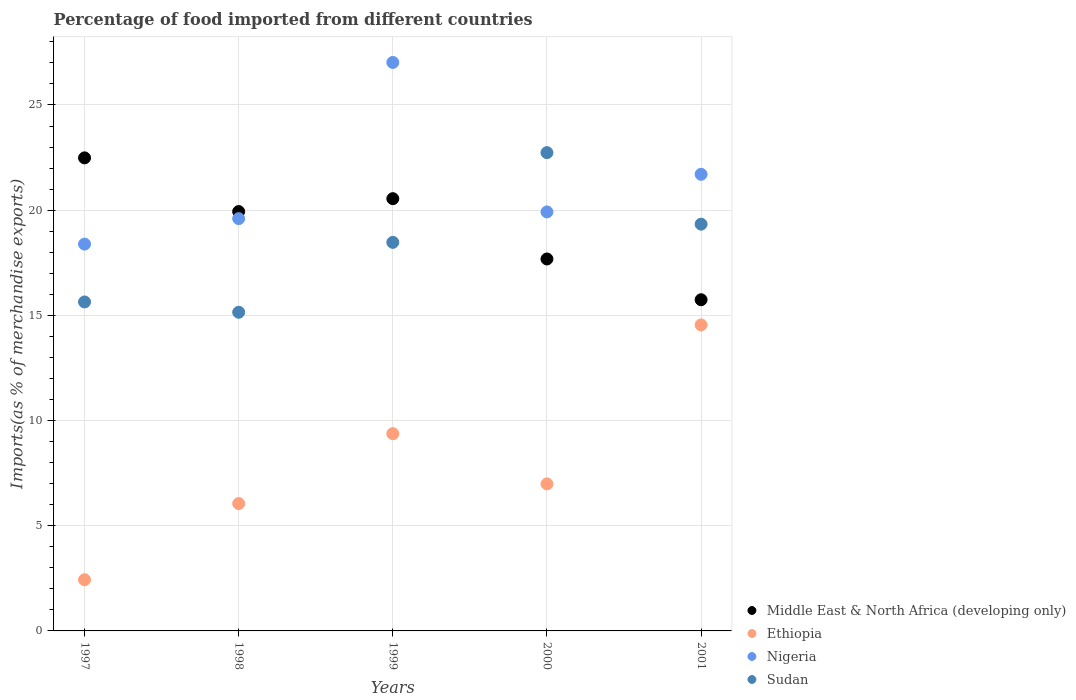How many different coloured dotlines are there?
Keep it short and to the point. 4. Is the number of dotlines equal to the number of legend labels?
Your response must be concise. Yes. What is the percentage of imports to different countries in Sudan in 1999?
Provide a succinct answer. 18.47. Across all years, what is the maximum percentage of imports to different countries in Middle East & North Africa (developing only)?
Provide a short and direct response. 22.49. Across all years, what is the minimum percentage of imports to different countries in Ethiopia?
Your response must be concise. 2.43. What is the total percentage of imports to different countries in Middle East & North Africa (developing only) in the graph?
Give a very brief answer. 96.39. What is the difference between the percentage of imports to different countries in Sudan in 1997 and that in 1999?
Ensure brevity in your answer.  -2.83. What is the difference between the percentage of imports to different countries in Middle East & North Africa (developing only) in 1997 and the percentage of imports to different countries in Sudan in 2001?
Give a very brief answer. 3.15. What is the average percentage of imports to different countries in Nigeria per year?
Make the answer very short. 21.33. In the year 1997, what is the difference between the percentage of imports to different countries in Nigeria and percentage of imports to different countries in Ethiopia?
Keep it short and to the point. 15.95. In how many years, is the percentage of imports to different countries in Nigeria greater than 6 %?
Offer a terse response. 5. What is the ratio of the percentage of imports to different countries in Nigeria in 1999 to that in 2000?
Your answer should be very brief. 1.36. Is the percentage of imports to different countries in Middle East & North Africa (developing only) in 1997 less than that in 1998?
Ensure brevity in your answer.  No. What is the difference between the highest and the second highest percentage of imports to different countries in Ethiopia?
Make the answer very short. 5.17. What is the difference between the highest and the lowest percentage of imports to different countries in Ethiopia?
Provide a succinct answer. 12.11. Does the percentage of imports to different countries in Nigeria monotonically increase over the years?
Offer a terse response. No. How many years are there in the graph?
Keep it short and to the point. 5. What is the difference between two consecutive major ticks on the Y-axis?
Your answer should be very brief. 5. Does the graph contain any zero values?
Provide a short and direct response. No. How are the legend labels stacked?
Ensure brevity in your answer.  Vertical. What is the title of the graph?
Your answer should be compact. Percentage of food imported from different countries. Does "Indonesia" appear as one of the legend labels in the graph?
Offer a very short reply. No. What is the label or title of the X-axis?
Give a very brief answer. Years. What is the label or title of the Y-axis?
Provide a short and direct response. Imports(as % of merchandise exports). What is the Imports(as % of merchandise exports) of Middle East & North Africa (developing only) in 1997?
Your answer should be very brief. 22.49. What is the Imports(as % of merchandise exports) of Ethiopia in 1997?
Your answer should be compact. 2.43. What is the Imports(as % of merchandise exports) of Nigeria in 1997?
Make the answer very short. 18.39. What is the Imports(as % of merchandise exports) in Sudan in 1997?
Your answer should be very brief. 15.64. What is the Imports(as % of merchandise exports) in Middle East & North Africa (developing only) in 1998?
Provide a succinct answer. 19.93. What is the Imports(as % of merchandise exports) in Ethiopia in 1998?
Keep it short and to the point. 6.05. What is the Imports(as % of merchandise exports) in Nigeria in 1998?
Offer a very short reply. 19.6. What is the Imports(as % of merchandise exports) of Sudan in 1998?
Ensure brevity in your answer.  15.15. What is the Imports(as % of merchandise exports) of Middle East & North Africa (developing only) in 1999?
Your answer should be compact. 20.55. What is the Imports(as % of merchandise exports) in Ethiopia in 1999?
Your answer should be compact. 9.38. What is the Imports(as % of merchandise exports) of Nigeria in 1999?
Your response must be concise. 27.02. What is the Imports(as % of merchandise exports) in Sudan in 1999?
Your response must be concise. 18.47. What is the Imports(as % of merchandise exports) in Middle East & North Africa (developing only) in 2000?
Keep it short and to the point. 17.68. What is the Imports(as % of merchandise exports) of Ethiopia in 2000?
Offer a very short reply. 6.99. What is the Imports(as % of merchandise exports) in Nigeria in 2000?
Ensure brevity in your answer.  19.92. What is the Imports(as % of merchandise exports) of Sudan in 2000?
Your answer should be very brief. 22.73. What is the Imports(as % of merchandise exports) of Middle East & North Africa (developing only) in 2001?
Provide a succinct answer. 15.74. What is the Imports(as % of merchandise exports) of Ethiopia in 2001?
Your response must be concise. 14.55. What is the Imports(as % of merchandise exports) in Nigeria in 2001?
Ensure brevity in your answer.  21.7. What is the Imports(as % of merchandise exports) of Sudan in 2001?
Keep it short and to the point. 19.33. Across all years, what is the maximum Imports(as % of merchandise exports) of Middle East & North Africa (developing only)?
Provide a succinct answer. 22.49. Across all years, what is the maximum Imports(as % of merchandise exports) in Ethiopia?
Your answer should be very brief. 14.55. Across all years, what is the maximum Imports(as % of merchandise exports) in Nigeria?
Keep it short and to the point. 27.02. Across all years, what is the maximum Imports(as % of merchandise exports) of Sudan?
Provide a succinct answer. 22.73. Across all years, what is the minimum Imports(as % of merchandise exports) in Middle East & North Africa (developing only)?
Make the answer very short. 15.74. Across all years, what is the minimum Imports(as % of merchandise exports) in Ethiopia?
Your answer should be compact. 2.43. Across all years, what is the minimum Imports(as % of merchandise exports) of Nigeria?
Ensure brevity in your answer.  18.39. Across all years, what is the minimum Imports(as % of merchandise exports) of Sudan?
Your answer should be compact. 15.15. What is the total Imports(as % of merchandise exports) of Middle East & North Africa (developing only) in the graph?
Provide a short and direct response. 96.39. What is the total Imports(as % of merchandise exports) of Ethiopia in the graph?
Offer a very short reply. 39.4. What is the total Imports(as % of merchandise exports) in Nigeria in the graph?
Keep it short and to the point. 106.63. What is the total Imports(as % of merchandise exports) of Sudan in the graph?
Ensure brevity in your answer.  91.32. What is the difference between the Imports(as % of merchandise exports) of Middle East & North Africa (developing only) in 1997 and that in 1998?
Ensure brevity in your answer.  2.55. What is the difference between the Imports(as % of merchandise exports) in Ethiopia in 1997 and that in 1998?
Keep it short and to the point. -3.62. What is the difference between the Imports(as % of merchandise exports) of Nigeria in 1997 and that in 1998?
Your answer should be compact. -1.21. What is the difference between the Imports(as % of merchandise exports) in Sudan in 1997 and that in 1998?
Your answer should be very brief. 0.49. What is the difference between the Imports(as % of merchandise exports) of Middle East & North Africa (developing only) in 1997 and that in 1999?
Make the answer very short. 1.94. What is the difference between the Imports(as % of merchandise exports) of Ethiopia in 1997 and that in 1999?
Your answer should be very brief. -6.94. What is the difference between the Imports(as % of merchandise exports) in Nigeria in 1997 and that in 1999?
Keep it short and to the point. -8.63. What is the difference between the Imports(as % of merchandise exports) in Sudan in 1997 and that in 1999?
Ensure brevity in your answer.  -2.83. What is the difference between the Imports(as % of merchandise exports) of Middle East & North Africa (developing only) in 1997 and that in 2000?
Provide a short and direct response. 4.81. What is the difference between the Imports(as % of merchandise exports) in Ethiopia in 1997 and that in 2000?
Provide a succinct answer. -4.56. What is the difference between the Imports(as % of merchandise exports) of Nigeria in 1997 and that in 2000?
Offer a very short reply. -1.53. What is the difference between the Imports(as % of merchandise exports) of Sudan in 1997 and that in 2000?
Your answer should be very brief. -7.1. What is the difference between the Imports(as % of merchandise exports) in Middle East & North Africa (developing only) in 1997 and that in 2001?
Ensure brevity in your answer.  6.74. What is the difference between the Imports(as % of merchandise exports) of Ethiopia in 1997 and that in 2001?
Make the answer very short. -12.11. What is the difference between the Imports(as % of merchandise exports) of Nigeria in 1997 and that in 2001?
Offer a very short reply. -3.32. What is the difference between the Imports(as % of merchandise exports) in Sudan in 1997 and that in 2001?
Provide a succinct answer. -3.7. What is the difference between the Imports(as % of merchandise exports) of Middle East & North Africa (developing only) in 1998 and that in 1999?
Your answer should be very brief. -0.61. What is the difference between the Imports(as % of merchandise exports) of Ethiopia in 1998 and that in 1999?
Give a very brief answer. -3.32. What is the difference between the Imports(as % of merchandise exports) of Nigeria in 1998 and that in 1999?
Give a very brief answer. -7.42. What is the difference between the Imports(as % of merchandise exports) in Sudan in 1998 and that in 1999?
Make the answer very short. -3.32. What is the difference between the Imports(as % of merchandise exports) of Middle East & North Africa (developing only) in 1998 and that in 2000?
Your answer should be very brief. 2.25. What is the difference between the Imports(as % of merchandise exports) of Ethiopia in 1998 and that in 2000?
Your response must be concise. -0.94. What is the difference between the Imports(as % of merchandise exports) of Nigeria in 1998 and that in 2000?
Provide a succinct answer. -0.32. What is the difference between the Imports(as % of merchandise exports) of Sudan in 1998 and that in 2000?
Provide a succinct answer. -7.59. What is the difference between the Imports(as % of merchandise exports) of Middle East & North Africa (developing only) in 1998 and that in 2001?
Provide a succinct answer. 4.19. What is the difference between the Imports(as % of merchandise exports) in Ethiopia in 1998 and that in 2001?
Keep it short and to the point. -8.49. What is the difference between the Imports(as % of merchandise exports) of Nigeria in 1998 and that in 2001?
Your answer should be compact. -2.11. What is the difference between the Imports(as % of merchandise exports) of Sudan in 1998 and that in 2001?
Ensure brevity in your answer.  -4.19. What is the difference between the Imports(as % of merchandise exports) in Middle East & North Africa (developing only) in 1999 and that in 2000?
Your answer should be very brief. 2.87. What is the difference between the Imports(as % of merchandise exports) of Ethiopia in 1999 and that in 2000?
Your answer should be compact. 2.39. What is the difference between the Imports(as % of merchandise exports) in Nigeria in 1999 and that in 2000?
Provide a succinct answer. 7.1. What is the difference between the Imports(as % of merchandise exports) of Sudan in 1999 and that in 2000?
Provide a succinct answer. -4.26. What is the difference between the Imports(as % of merchandise exports) in Middle East & North Africa (developing only) in 1999 and that in 2001?
Make the answer very short. 4.8. What is the difference between the Imports(as % of merchandise exports) in Ethiopia in 1999 and that in 2001?
Give a very brief answer. -5.17. What is the difference between the Imports(as % of merchandise exports) in Nigeria in 1999 and that in 2001?
Provide a short and direct response. 5.32. What is the difference between the Imports(as % of merchandise exports) in Sudan in 1999 and that in 2001?
Offer a terse response. -0.87. What is the difference between the Imports(as % of merchandise exports) of Middle East & North Africa (developing only) in 2000 and that in 2001?
Give a very brief answer. 1.94. What is the difference between the Imports(as % of merchandise exports) of Ethiopia in 2000 and that in 2001?
Offer a very short reply. -7.56. What is the difference between the Imports(as % of merchandise exports) of Nigeria in 2000 and that in 2001?
Offer a terse response. -1.79. What is the difference between the Imports(as % of merchandise exports) of Sudan in 2000 and that in 2001?
Your answer should be very brief. 3.4. What is the difference between the Imports(as % of merchandise exports) of Middle East & North Africa (developing only) in 1997 and the Imports(as % of merchandise exports) of Ethiopia in 1998?
Your response must be concise. 16.43. What is the difference between the Imports(as % of merchandise exports) in Middle East & North Africa (developing only) in 1997 and the Imports(as % of merchandise exports) in Nigeria in 1998?
Your answer should be compact. 2.89. What is the difference between the Imports(as % of merchandise exports) in Middle East & North Africa (developing only) in 1997 and the Imports(as % of merchandise exports) in Sudan in 1998?
Your response must be concise. 7.34. What is the difference between the Imports(as % of merchandise exports) of Ethiopia in 1997 and the Imports(as % of merchandise exports) of Nigeria in 1998?
Offer a terse response. -17.16. What is the difference between the Imports(as % of merchandise exports) in Ethiopia in 1997 and the Imports(as % of merchandise exports) in Sudan in 1998?
Provide a succinct answer. -12.71. What is the difference between the Imports(as % of merchandise exports) of Nigeria in 1997 and the Imports(as % of merchandise exports) of Sudan in 1998?
Offer a terse response. 3.24. What is the difference between the Imports(as % of merchandise exports) in Middle East & North Africa (developing only) in 1997 and the Imports(as % of merchandise exports) in Ethiopia in 1999?
Offer a very short reply. 13.11. What is the difference between the Imports(as % of merchandise exports) in Middle East & North Africa (developing only) in 1997 and the Imports(as % of merchandise exports) in Nigeria in 1999?
Your answer should be compact. -4.54. What is the difference between the Imports(as % of merchandise exports) in Middle East & North Africa (developing only) in 1997 and the Imports(as % of merchandise exports) in Sudan in 1999?
Provide a succinct answer. 4.02. What is the difference between the Imports(as % of merchandise exports) in Ethiopia in 1997 and the Imports(as % of merchandise exports) in Nigeria in 1999?
Provide a succinct answer. -24.59. What is the difference between the Imports(as % of merchandise exports) of Ethiopia in 1997 and the Imports(as % of merchandise exports) of Sudan in 1999?
Give a very brief answer. -16.04. What is the difference between the Imports(as % of merchandise exports) of Nigeria in 1997 and the Imports(as % of merchandise exports) of Sudan in 1999?
Provide a succinct answer. -0.08. What is the difference between the Imports(as % of merchandise exports) in Middle East & North Africa (developing only) in 1997 and the Imports(as % of merchandise exports) in Ethiopia in 2000?
Keep it short and to the point. 15.5. What is the difference between the Imports(as % of merchandise exports) of Middle East & North Africa (developing only) in 1997 and the Imports(as % of merchandise exports) of Nigeria in 2000?
Provide a short and direct response. 2.57. What is the difference between the Imports(as % of merchandise exports) in Middle East & North Africa (developing only) in 1997 and the Imports(as % of merchandise exports) in Sudan in 2000?
Ensure brevity in your answer.  -0.25. What is the difference between the Imports(as % of merchandise exports) in Ethiopia in 1997 and the Imports(as % of merchandise exports) in Nigeria in 2000?
Ensure brevity in your answer.  -17.48. What is the difference between the Imports(as % of merchandise exports) in Ethiopia in 1997 and the Imports(as % of merchandise exports) in Sudan in 2000?
Your answer should be very brief. -20.3. What is the difference between the Imports(as % of merchandise exports) of Nigeria in 1997 and the Imports(as % of merchandise exports) of Sudan in 2000?
Keep it short and to the point. -4.35. What is the difference between the Imports(as % of merchandise exports) in Middle East & North Africa (developing only) in 1997 and the Imports(as % of merchandise exports) in Ethiopia in 2001?
Keep it short and to the point. 7.94. What is the difference between the Imports(as % of merchandise exports) of Middle East & North Africa (developing only) in 1997 and the Imports(as % of merchandise exports) of Nigeria in 2001?
Ensure brevity in your answer.  0.78. What is the difference between the Imports(as % of merchandise exports) in Middle East & North Africa (developing only) in 1997 and the Imports(as % of merchandise exports) in Sudan in 2001?
Offer a very short reply. 3.15. What is the difference between the Imports(as % of merchandise exports) in Ethiopia in 1997 and the Imports(as % of merchandise exports) in Nigeria in 2001?
Your answer should be very brief. -19.27. What is the difference between the Imports(as % of merchandise exports) in Ethiopia in 1997 and the Imports(as % of merchandise exports) in Sudan in 2001?
Ensure brevity in your answer.  -16.9. What is the difference between the Imports(as % of merchandise exports) of Nigeria in 1997 and the Imports(as % of merchandise exports) of Sudan in 2001?
Keep it short and to the point. -0.95. What is the difference between the Imports(as % of merchandise exports) in Middle East & North Africa (developing only) in 1998 and the Imports(as % of merchandise exports) in Ethiopia in 1999?
Keep it short and to the point. 10.56. What is the difference between the Imports(as % of merchandise exports) in Middle East & North Africa (developing only) in 1998 and the Imports(as % of merchandise exports) in Nigeria in 1999?
Your answer should be compact. -7.09. What is the difference between the Imports(as % of merchandise exports) of Middle East & North Africa (developing only) in 1998 and the Imports(as % of merchandise exports) of Sudan in 1999?
Provide a succinct answer. 1.47. What is the difference between the Imports(as % of merchandise exports) of Ethiopia in 1998 and the Imports(as % of merchandise exports) of Nigeria in 1999?
Provide a succinct answer. -20.97. What is the difference between the Imports(as % of merchandise exports) of Ethiopia in 1998 and the Imports(as % of merchandise exports) of Sudan in 1999?
Keep it short and to the point. -12.42. What is the difference between the Imports(as % of merchandise exports) of Nigeria in 1998 and the Imports(as % of merchandise exports) of Sudan in 1999?
Give a very brief answer. 1.13. What is the difference between the Imports(as % of merchandise exports) of Middle East & North Africa (developing only) in 1998 and the Imports(as % of merchandise exports) of Ethiopia in 2000?
Provide a short and direct response. 12.95. What is the difference between the Imports(as % of merchandise exports) in Middle East & North Africa (developing only) in 1998 and the Imports(as % of merchandise exports) in Nigeria in 2000?
Your answer should be compact. 0.02. What is the difference between the Imports(as % of merchandise exports) in Middle East & North Africa (developing only) in 1998 and the Imports(as % of merchandise exports) in Sudan in 2000?
Give a very brief answer. -2.8. What is the difference between the Imports(as % of merchandise exports) in Ethiopia in 1998 and the Imports(as % of merchandise exports) in Nigeria in 2000?
Keep it short and to the point. -13.86. What is the difference between the Imports(as % of merchandise exports) in Ethiopia in 1998 and the Imports(as % of merchandise exports) in Sudan in 2000?
Give a very brief answer. -16.68. What is the difference between the Imports(as % of merchandise exports) of Nigeria in 1998 and the Imports(as % of merchandise exports) of Sudan in 2000?
Offer a very short reply. -3.14. What is the difference between the Imports(as % of merchandise exports) in Middle East & North Africa (developing only) in 1998 and the Imports(as % of merchandise exports) in Ethiopia in 2001?
Give a very brief answer. 5.39. What is the difference between the Imports(as % of merchandise exports) of Middle East & North Africa (developing only) in 1998 and the Imports(as % of merchandise exports) of Nigeria in 2001?
Your answer should be compact. -1.77. What is the difference between the Imports(as % of merchandise exports) in Middle East & North Africa (developing only) in 1998 and the Imports(as % of merchandise exports) in Sudan in 2001?
Your response must be concise. 0.6. What is the difference between the Imports(as % of merchandise exports) in Ethiopia in 1998 and the Imports(as % of merchandise exports) in Nigeria in 2001?
Keep it short and to the point. -15.65. What is the difference between the Imports(as % of merchandise exports) of Ethiopia in 1998 and the Imports(as % of merchandise exports) of Sudan in 2001?
Your answer should be compact. -13.28. What is the difference between the Imports(as % of merchandise exports) in Nigeria in 1998 and the Imports(as % of merchandise exports) in Sudan in 2001?
Provide a succinct answer. 0.26. What is the difference between the Imports(as % of merchandise exports) in Middle East & North Africa (developing only) in 1999 and the Imports(as % of merchandise exports) in Ethiopia in 2000?
Ensure brevity in your answer.  13.56. What is the difference between the Imports(as % of merchandise exports) in Middle East & North Africa (developing only) in 1999 and the Imports(as % of merchandise exports) in Nigeria in 2000?
Your answer should be very brief. 0.63. What is the difference between the Imports(as % of merchandise exports) in Middle East & North Africa (developing only) in 1999 and the Imports(as % of merchandise exports) in Sudan in 2000?
Ensure brevity in your answer.  -2.19. What is the difference between the Imports(as % of merchandise exports) in Ethiopia in 1999 and the Imports(as % of merchandise exports) in Nigeria in 2000?
Your response must be concise. -10.54. What is the difference between the Imports(as % of merchandise exports) of Ethiopia in 1999 and the Imports(as % of merchandise exports) of Sudan in 2000?
Your answer should be compact. -13.36. What is the difference between the Imports(as % of merchandise exports) in Nigeria in 1999 and the Imports(as % of merchandise exports) in Sudan in 2000?
Your response must be concise. 4.29. What is the difference between the Imports(as % of merchandise exports) in Middle East & North Africa (developing only) in 1999 and the Imports(as % of merchandise exports) in Ethiopia in 2001?
Make the answer very short. 6. What is the difference between the Imports(as % of merchandise exports) of Middle East & North Africa (developing only) in 1999 and the Imports(as % of merchandise exports) of Nigeria in 2001?
Your answer should be compact. -1.16. What is the difference between the Imports(as % of merchandise exports) in Middle East & North Africa (developing only) in 1999 and the Imports(as % of merchandise exports) in Sudan in 2001?
Offer a terse response. 1.21. What is the difference between the Imports(as % of merchandise exports) of Ethiopia in 1999 and the Imports(as % of merchandise exports) of Nigeria in 2001?
Keep it short and to the point. -12.33. What is the difference between the Imports(as % of merchandise exports) in Ethiopia in 1999 and the Imports(as % of merchandise exports) in Sudan in 2001?
Give a very brief answer. -9.96. What is the difference between the Imports(as % of merchandise exports) of Nigeria in 1999 and the Imports(as % of merchandise exports) of Sudan in 2001?
Provide a short and direct response. 7.69. What is the difference between the Imports(as % of merchandise exports) of Middle East & North Africa (developing only) in 2000 and the Imports(as % of merchandise exports) of Ethiopia in 2001?
Make the answer very short. 3.13. What is the difference between the Imports(as % of merchandise exports) of Middle East & North Africa (developing only) in 2000 and the Imports(as % of merchandise exports) of Nigeria in 2001?
Offer a very short reply. -4.02. What is the difference between the Imports(as % of merchandise exports) of Middle East & North Africa (developing only) in 2000 and the Imports(as % of merchandise exports) of Sudan in 2001?
Offer a very short reply. -1.65. What is the difference between the Imports(as % of merchandise exports) of Ethiopia in 2000 and the Imports(as % of merchandise exports) of Nigeria in 2001?
Keep it short and to the point. -14.71. What is the difference between the Imports(as % of merchandise exports) in Ethiopia in 2000 and the Imports(as % of merchandise exports) in Sudan in 2001?
Your answer should be very brief. -12.35. What is the difference between the Imports(as % of merchandise exports) of Nigeria in 2000 and the Imports(as % of merchandise exports) of Sudan in 2001?
Give a very brief answer. 0.58. What is the average Imports(as % of merchandise exports) of Middle East & North Africa (developing only) per year?
Your answer should be compact. 19.28. What is the average Imports(as % of merchandise exports) in Ethiopia per year?
Give a very brief answer. 7.88. What is the average Imports(as % of merchandise exports) in Nigeria per year?
Provide a succinct answer. 21.33. What is the average Imports(as % of merchandise exports) of Sudan per year?
Provide a short and direct response. 18.26. In the year 1997, what is the difference between the Imports(as % of merchandise exports) of Middle East & North Africa (developing only) and Imports(as % of merchandise exports) of Ethiopia?
Your response must be concise. 20.05. In the year 1997, what is the difference between the Imports(as % of merchandise exports) in Middle East & North Africa (developing only) and Imports(as % of merchandise exports) in Nigeria?
Offer a very short reply. 4.1. In the year 1997, what is the difference between the Imports(as % of merchandise exports) in Middle East & North Africa (developing only) and Imports(as % of merchandise exports) in Sudan?
Keep it short and to the point. 6.85. In the year 1997, what is the difference between the Imports(as % of merchandise exports) in Ethiopia and Imports(as % of merchandise exports) in Nigeria?
Provide a short and direct response. -15.95. In the year 1997, what is the difference between the Imports(as % of merchandise exports) of Ethiopia and Imports(as % of merchandise exports) of Sudan?
Give a very brief answer. -13.2. In the year 1997, what is the difference between the Imports(as % of merchandise exports) of Nigeria and Imports(as % of merchandise exports) of Sudan?
Your answer should be very brief. 2.75. In the year 1998, what is the difference between the Imports(as % of merchandise exports) in Middle East & North Africa (developing only) and Imports(as % of merchandise exports) in Ethiopia?
Ensure brevity in your answer.  13.88. In the year 1998, what is the difference between the Imports(as % of merchandise exports) of Middle East & North Africa (developing only) and Imports(as % of merchandise exports) of Nigeria?
Ensure brevity in your answer.  0.34. In the year 1998, what is the difference between the Imports(as % of merchandise exports) in Middle East & North Africa (developing only) and Imports(as % of merchandise exports) in Sudan?
Your response must be concise. 4.79. In the year 1998, what is the difference between the Imports(as % of merchandise exports) in Ethiopia and Imports(as % of merchandise exports) in Nigeria?
Keep it short and to the point. -13.54. In the year 1998, what is the difference between the Imports(as % of merchandise exports) of Ethiopia and Imports(as % of merchandise exports) of Sudan?
Provide a short and direct response. -9.09. In the year 1998, what is the difference between the Imports(as % of merchandise exports) in Nigeria and Imports(as % of merchandise exports) in Sudan?
Your response must be concise. 4.45. In the year 1999, what is the difference between the Imports(as % of merchandise exports) in Middle East & North Africa (developing only) and Imports(as % of merchandise exports) in Ethiopia?
Ensure brevity in your answer.  11.17. In the year 1999, what is the difference between the Imports(as % of merchandise exports) in Middle East & North Africa (developing only) and Imports(as % of merchandise exports) in Nigeria?
Your answer should be very brief. -6.48. In the year 1999, what is the difference between the Imports(as % of merchandise exports) of Middle East & North Africa (developing only) and Imports(as % of merchandise exports) of Sudan?
Offer a very short reply. 2.08. In the year 1999, what is the difference between the Imports(as % of merchandise exports) of Ethiopia and Imports(as % of merchandise exports) of Nigeria?
Keep it short and to the point. -17.64. In the year 1999, what is the difference between the Imports(as % of merchandise exports) in Ethiopia and Imports(as % of merchandise exports) in Sudan?
Give a very brief answer. -9.09. In the year 1999, what is the difference between the Imports(as % of merchandise exports) of Nigeria and Imports(as % of merchandise exports) of Sudan?
Your response must be concise. 8.55. In the year 2000, what is the difference between the Imports(as % of merchandise exports) in Middle East & North Africa (developing only) and Imports(as % of merchandise exports) in Ethiopia?
Provide a succinct answer. 10.69. In the year 2000, what is the difference between the Imports(as % of merchandise exports) in Middle East & North Africa (developing only) and Imports(as % of merchandise exports) in Nigeria?
Make the answer very short. -2.24. In the year 2000, what is the difference between the Imports(as % of merchandise exports) in Middle East & North Africa (developing only) and Imports(as % of merchandise exports) in Sudan?
Make the answer very short. -5.05. In the year 2000, what is the difference between the Imports(as % of merchandise exports) of Ethiopia and Imports(as % of merchandise exports) of Nigeria?
Provide a short and direct response. -12.93. In the year 2000, what is the difference between the Imports(as % of merchandise exports) of Ethiopia and Imports(as % of merchandise exports) of Sudan?
Provide a succinct answer. -15.74. In the year 2000, what is the difference between the Imports(as % of merchandise exports) of Nigeria and Imports(as % of merchandise exports) of Sudan?
Provide a succinct answer. -2.82. In the year 2001, what is the difference between the Imports(as % of merchandise exports) of Middle East & North Africa (developing only) and Imports(as % of merchandise exports) of Ethiopia?
Offer a terse response. 1.2. In the year 2001, what is the difference between the Imports(as % of merchandise exports) of Middle East & North Africa (developing only) and Imports(as % of merchandise exports) of Nigeria?
Keep it short and to the point. -5.96. In the year 2001, what is the difference between the Imports(as % of merchandise exports) in Middle East & North Africa (developing only) and Imports(as % of merchandise exports) in Sudan?
Provide a short and direct response. -3.59. In the year 2001, what is the difference between the Imports(as % of merchandise exports) of Ethiopia and Imports(as % of merchandise exports) of Nigeria?
Your answer should be very brief. -7.16. In the year 2001, what is the difference between the Imports(as % of merchandise exports) in Ethiopia and Imports(as % of merchandise exports) in Sudan?
Make the answer very short. -4.79. In the year 2001, what is the difference between the Imports(as % of merchandise exports) in Nigeria and Imports(as % of merchandise exports) in Sudan?
Offer a very short reply. 2.37. What is the ratio of the Imports(as % of merchandise exports) of Middle East & North Africa (developing only) in 1997 to that in 1998?
Offer a terse response. 1.13. What is the ratio of the Imports(as % of merchandise exports) in Ethiopia in 1997 to that in 1998?
Your answer should be compact. 0.4. What is the ratio of the Imports(as % of merchandise exports) in Nigeria in 1997 to that in 1998?
Ensure brevity in your answer.  0.94. What is the ratio of the Imports(as % of merchandise exports) in Sudan in 1997 to that in 1998?
Give a very brief answer. 1.03. What is the ratio of the Imports(as % of merchandise exports) of Middle East & North Africa (developing only) in 1997 to that in 1999?
Provide a succinct answer. 1.09. What is the ratio of the Imports(as % of merchandise exports) of Ethiopia in 1997 to that in 1999?
Your answer should be very brief. 0.26. What is the ratio of the Imports(as % of merchandise exports) in Nigeria in 1997 to that in 1999?
Ensure brevity in your answer.  0.68. What is the ratio of the Imports(as % of merchandise exports) in Sudan in 1997 to that in 1999?
Make the answer very short. 0.85. What is the ratio of the Imports(as % of merchandise exports) of Middle East & North Africa (developing only) in 1997 to that in 2000?
Keep it short and to the point. 1.27. What is the ratio of the Imports(as % of merchandise exports) in Ethiopia in 1997 to that in 2000?
Provide a succinct answer. 0.35. What is the ratio of the Imports(as % of merchandise exports) of Nigeria in 1997 to that in 2000?
Ensure brevity in your answer.  0.92. What is the ratio of the Imports(as % of merchandise exports) in Sudan in 1997 to that in 2000?
Your answer should be very brief. 0.69. What is the ratio of the Imports(as % of merchandise exports) of Middle East & North Africa (developing only) in 1997 to that in 2001?
Your response must be concise. 1.43. What is the ratio of the Imports(as % of merchandise exports) of Ethiopia in 1997 to that in 2001?
Your answer should be compact. 0.17. What is the ratio of the Imports(as % of merchandise exports) of Nigeria in 1997 to that in 2001?
Offer a very short reply. 0.85. What is the ratio of the Imports(as % of merchandise exports) in Sudan in 1997 to that in 2001?
Offer a terse response. 0.81. What is the ratio of the Imports(as % of merchandise exports) of Middle East & North Africa (developing only) in 1998 to that in 1999?
Ensure brevity in your answer.  0.97. What is the ratio of the Imports(as % of merchandise exports) of Ethiopia in 1998 to that in 1999?
Offer a very short reply. 0.65. What is the ratio of the Imports(as % of merchandise exports) in Nigeria in 1998 to that in 1999?
Your answer should be very brief. 0.73. What is the ratio of the Imports(as % of merchandise exports) in Sudan in 1998 to that in 1999?
Offer a very short reply. 0.82. What is the ratio of the Imports(as % of merchandise exports) in Middle East & North Africa (developing only) in 1998 to that in 2000?
Make the answer very short. 1.13. What is the ratio of the Imports(as % of merchandise exports) in Ethiopia in 1998 to that in 2000?
Keep it short and to the point. 0.87. What is the ratio of the Imports(as % of merchandise exports) in Nigeria in 1998 to that in 2000?
Provide a short and direct response. 0.98. What is the ratio of the Imports(as % of merchandise exports) in Sudan in 1998 to that in 2000?
Your answer should be very brief. 0.67. What is the ratio of the Imports(as % of merchandise exports) in Middle East & North Africa (developing only) in 1998 to that in 2001?
Ensure brevity in your answer.  1.27. What is the ratio of the Imports(as % of merchandise exports) in Ethiopia in 1998 to that in 2001?
Your answer should be very brief. 0.42. What is the ratio of the Imports(as % of merchandise exports) of Nigeria in 1998 to that in 2001?
Keep it short and to the point. 0.9. What is the ratio of the Imports(as % of merchandise exports) in Sudan in 1998 to that in 2001?
Keep it short and to the point. 0.78. What is the ratio of the Imports(as % of merchandise exports) in Middle East & North Africa (developing only) in 1999 to that in 2000?
Provide a succinct answer. 1.16. What is the ratio of the Imports(as % of merchandise exports) of Ethiopia in 1999 to that in 2000?
Give a very brief answer. 1.34. What is the ratio of the Imports(as % of merchandise exports) of Nigeria in 1999 to that in 2000?
Offer a very short reply. 1.36. What is the ratio of the Imports(as % of merchandise exports) of Sudan in 1999 to that in 2000?
Offer a very short reply. 0.81. What is the ratio of the Imports(as % of merchandise exports) in Middle East & North Africa (developing only) in 1999 to that in 2001?
Your answer should be very brief. 1.31. What is the ratio of the Imports(as % of merchandise exports) in Ethiopia in 1999 to that in 2001?
Offer a terse response. 0.64. What is the ratio of the Imports(as % of merchandise exports) in Nigeria in 1999 to that in 2001?
Provide a short and direct response. 1.25. What is the ratio of the Imports(as % of merchandise exports) of Sudan in 1999 to that in 2001?
Provide a succinct answer. 0.96. What is the ratio of the Imports(as % of merchandise exports) of Middle East & North Africa (developing only) in 2000 to that in 2001?
Give a very brief answer. 1.12. What is the ratio of the Imports(as % of merchandise exports) in Ethiopia in 2000 to that in 2001?
Your response must be concise. 0.48. What is the ratio of the Imports(as % of merchandise exports) of Nigeria in 2000 to that in 2001?
Ensure brevity in your answer.  0.92. What is the ratio of the Imports(as % of merchandise exports) of Sudan in 2000 to that in 2001?
Provide a succinct answer. 1.18. What is the difference between the highest and the second highest Imports(as % of merchandise exports) of Middle East & North Africa (developing only)?
Provide a succinct answer. 1.94. What is the difference between the highest and the second highest Imports(as % of merchandise exports) of Ethiopia?
Offer a terse response. 5.17. What is the difference between the highest and the second highest Imports(as % of merchandise exports) of Nigeria?
Offer a terse response. 5.32. What is the difference between the highest and the second highest Imports(as % of merchandise exports) in Sudan?
Provide a succinct answer. 3.4. What is the difference between the highest and the lowest Imports(as % of merchandise exports) of Middle East & North Africa (developing only)?
Give a very brief answer. 6.74. What is the difference between the highest and the lowest Imports(as % of merchandise exports) in Ethiopia?
Offer a very short reply. 12.11. What is the difference between the highest and the lowest Imports(as % of merchandise exports) of Nigeria?
Provide a short and direct response. 8.63. What is the difference between the highest and the lowest Imports(as % of merchandise exports) of Sudan?
Provide a succinct answer. 7.59. 